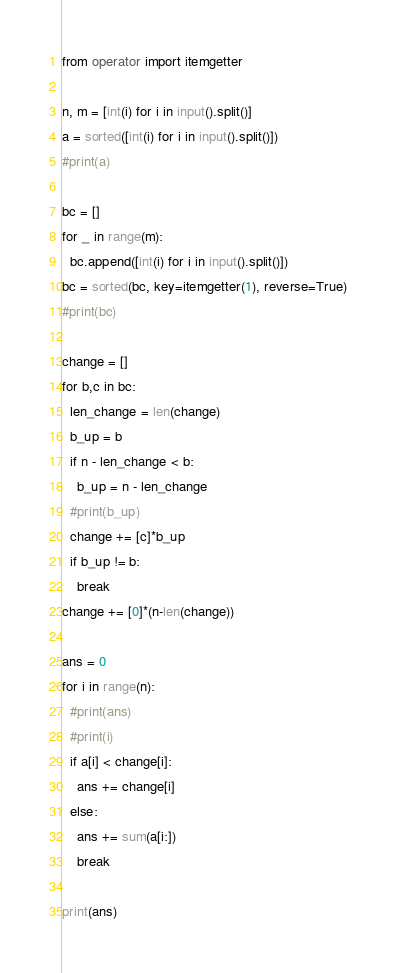<code> <loc_0><loc_0><loc_500><loc_500><_Python_>from operator import itemgetter

n, m = [int(i) for i in input().split()]
a = sorted([int(i) for i in input().split()])
#print(a)

bc = []
for _ in range(m):
  bc.append([int(i) for i in input().split()])
bc = sorted(bc, key=itemgetter(1), reverse=True)
#print(bc)

change = []
for b,c in bc:
  len_change = len(change)
  b_up = b
  if n - len_change < b:
    b_up = n - len_change
  #print(b_up)
  change += [c]*b_up
  if b_up != b:
    break
change += [0]*(n-len(change))

ans = 0
for i in range(n):
  #print(ans)
  #print(i)
  if a[i] < change[i]:
    ans += change[i]
  else:
    ans += sum(a[i:])
    break
    
print(ans)</code> 